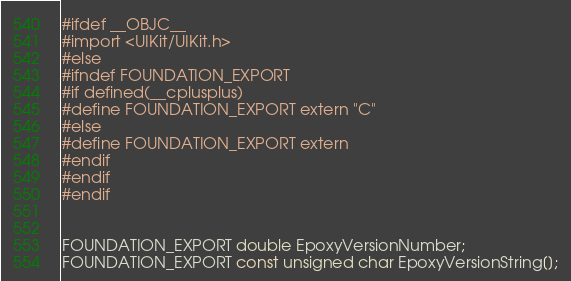Convert code to text. <code><loc_0><loc_0><loc_500><loc_500><_C_>#ifdef __OBJC__
#import <UIKit/UIKit.h>
#else
#ifndef FOUNDATION_EXPORT
#if defined(__cplusplus)
#define FOUNDATION_EXPORT extern "C"
#else
#define FOUNDATION_EXPORT extern
#endif
#endif
#endif


FOUNDATION_EXPORT double EpoxyVersionNumber;
FOUNDATION_EXPORT const unsigned char EpoxyVersionString[];

</code> 